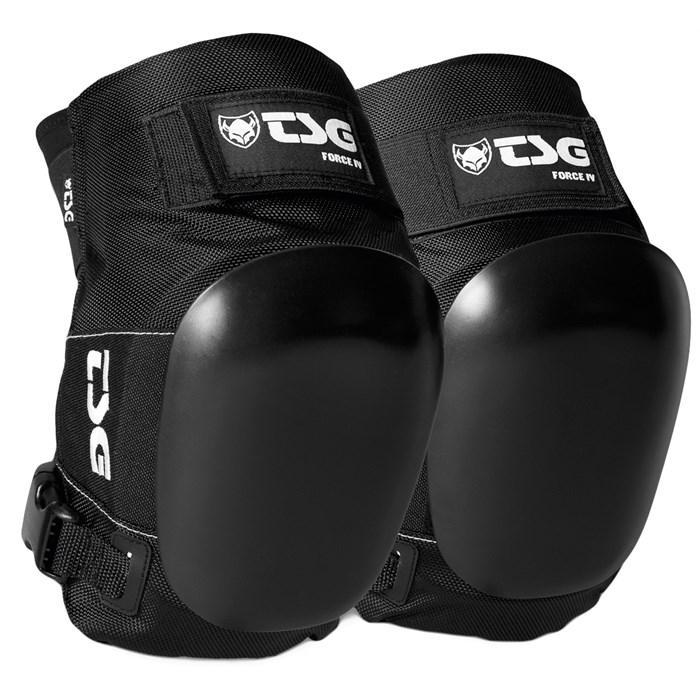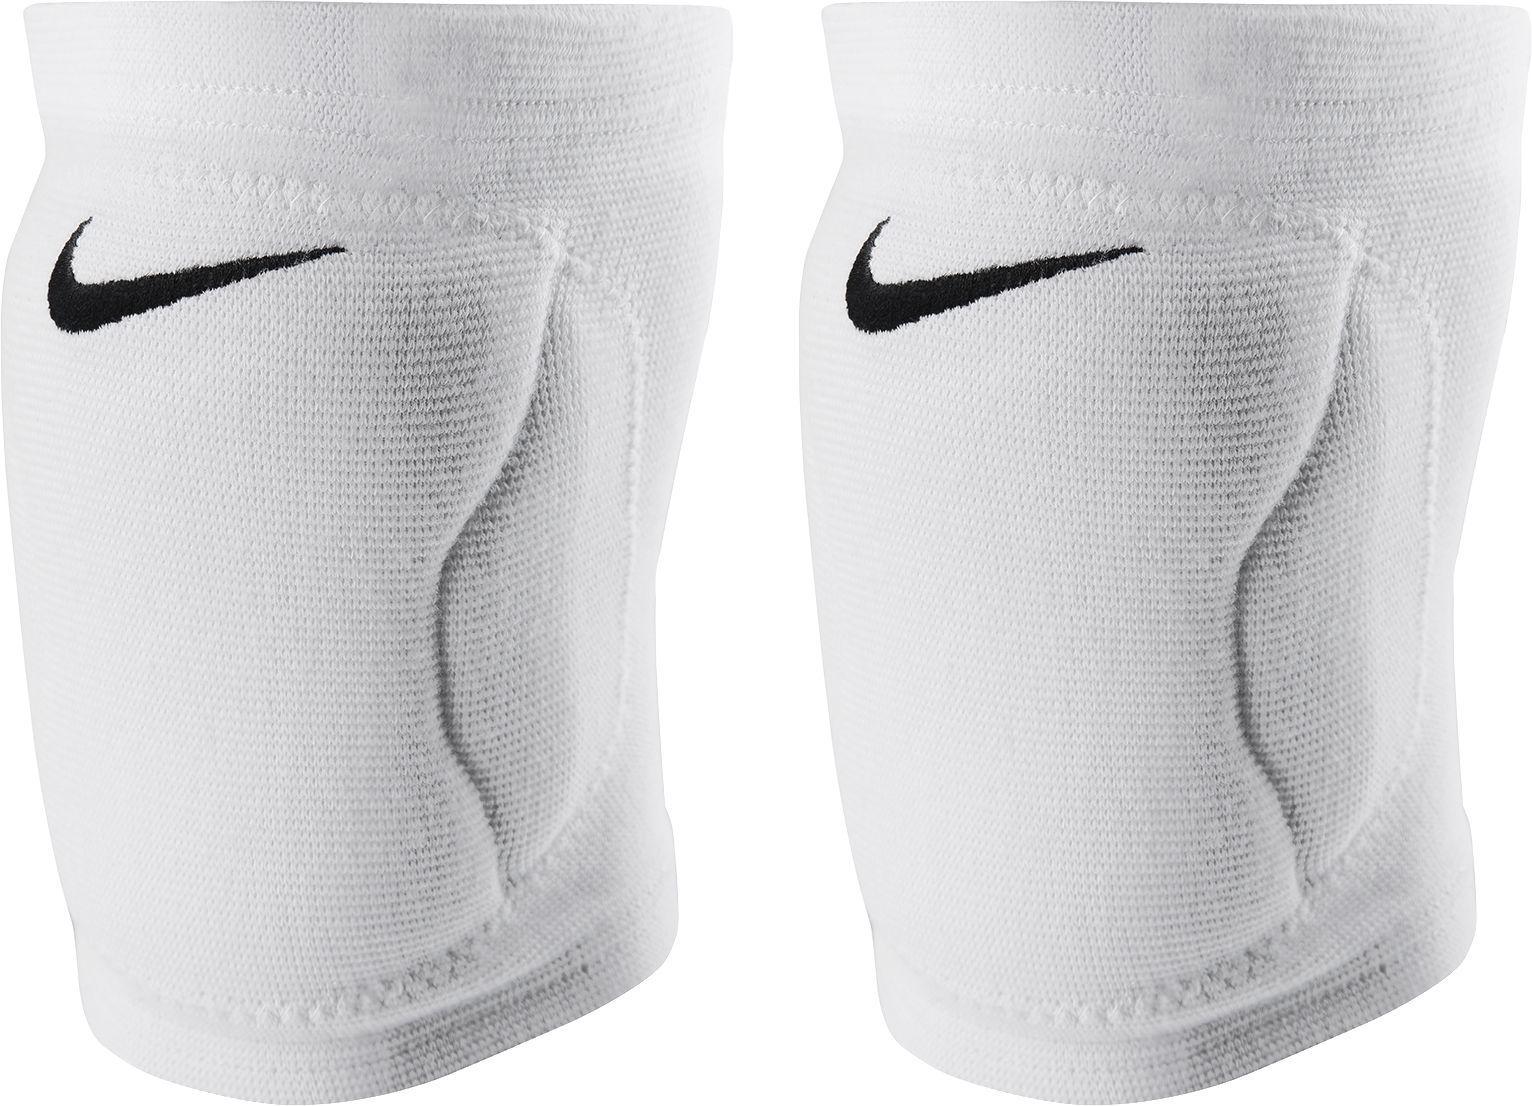The first image is the image on the left, the second image is the image on the right. Considering the images on both sides, is "There are two legs in the image on the right." valid? Answer yes or no. No. 